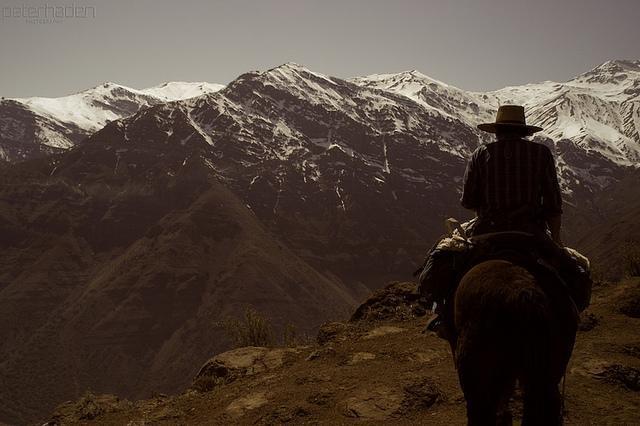How many green bottles are on the table?
Give a very brief answer. 0. 